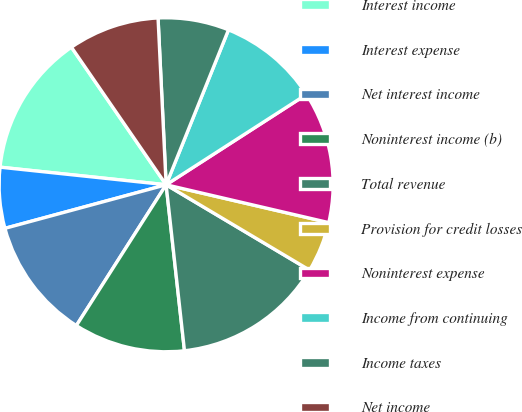Convert chart to OTSL. <chart><loc_0><loc_0><loc_500><loc_500><pie_chart><fcel>Interest income<fcel>Interest expense<fcel>Net interest income<fcel>Noninterest income (b)<fcel>Total revenue<fcel>Provision for credit losses<fcel>Noninterest expense<fcel>Income from continuing<fcel>Income taxes<fcel>Net income<nl><fcel>13.72%<fcel>5.88%<fcel>11.76%<fcel>10.78%<fcel>14.7%<fcel>4.9%<fcel>12.74%<fcel>9.8%<fcel>6.86%<fcel>8.82%<nl></chart> 